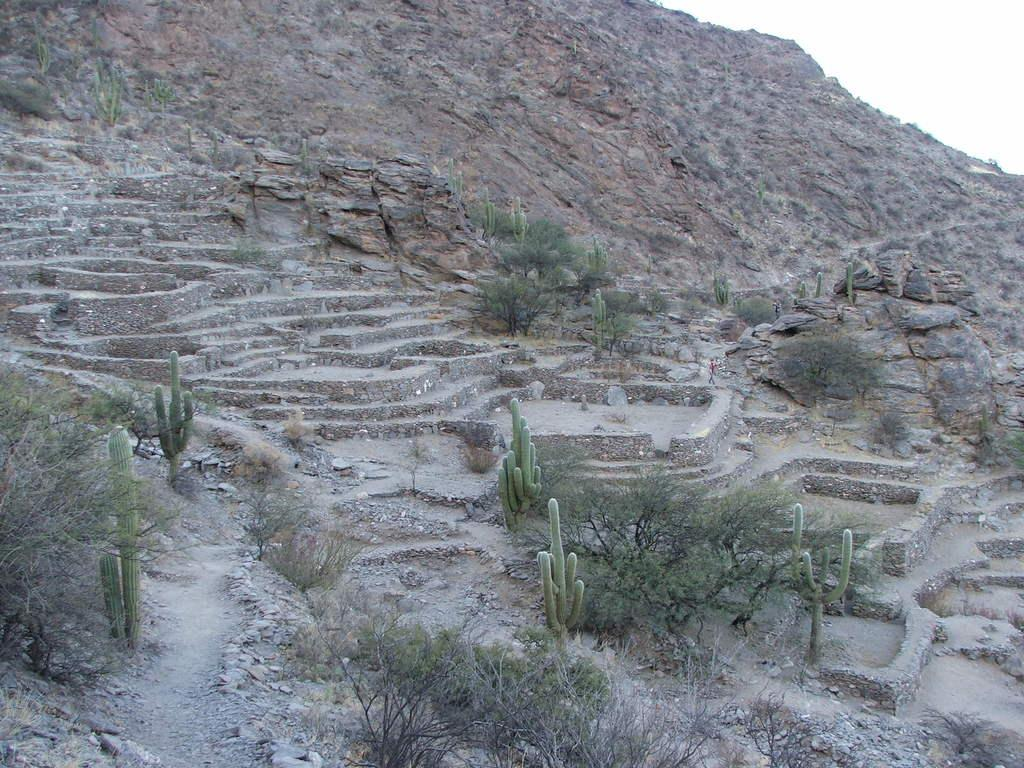Who or what is present in the image? There is a person in the image. Where is the person located? The person is on the stairs. What else can be seen in the image besides the person? There are plants, a mountain, and the sky visible in the image. What color is the fan in the image? There is no fan present in the image. How many wheels can be seen on the mountain in the image? There are no wheels on the mountain in the image; it is a natural formation. 